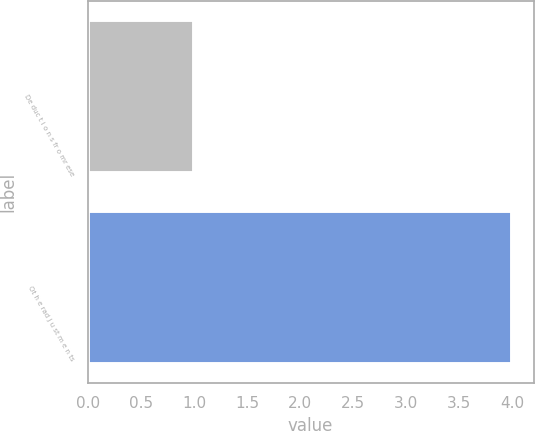<chart> <loc_0><loc_0><loc_500><loc_500><bar_chart><fcel>De duc t i o n s fr o mr ese<fcel>Ot h e rad j u st m e n ts<nl><fcel>1<fcel>4<nl></chart> 